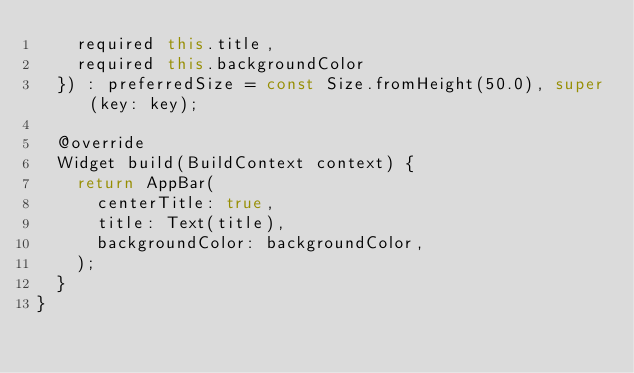<code> <loc_0><loc_0><loc_500><loc_500><_Dart_>    required this.title, 
    required this.backgroundColor
  }) : preferredSize = const Size.fromHeight(50.0), super(key: key);

  @override
  Widget build(BuildContext context) {
    return AppBar(
      centerTitle: true,
      title: Text(title),
      backgroundColor: backgroundColor,
    );
  }
}</code> 